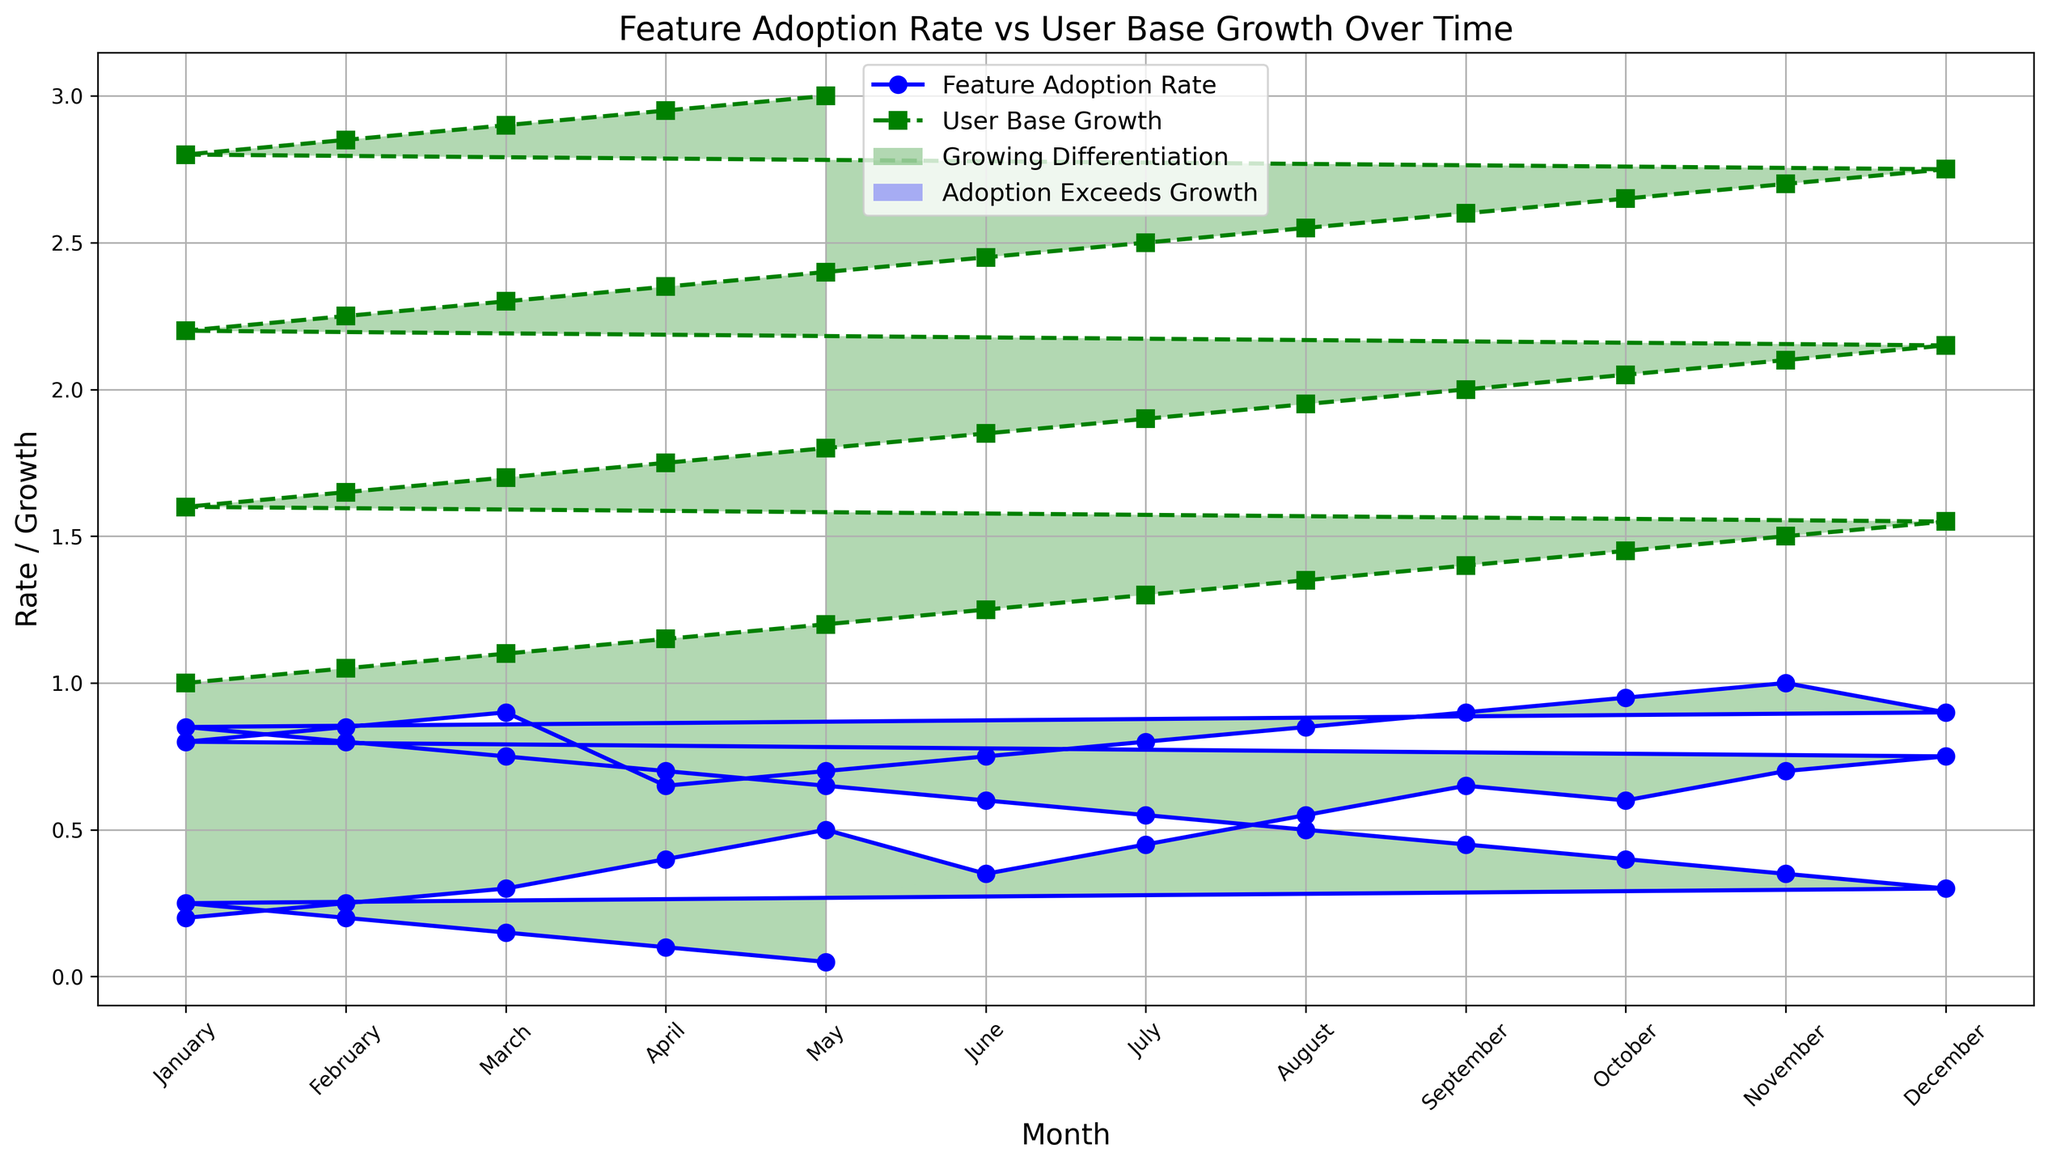What are the months where the Feature Adoption Rate is highest and lowest? We need to identify the months with the highest and lowest points on the blue line representing Feature Adoption Rate. The highest is observed in November (1.0), and the lowest in May (0.05).
Answer: November, May In which months does the Feature Adoption Rate exceed User Base Growth? We need to look for the months where the blue line (Feature Adoption Rate) is above the green line (User Base Growth). This occurs in November (1.0) and some subsequent months all the way to December before January when it starts dropping.
Answer: November, December What's the average User Base Growth over the months? To find the average, sum up all the User Base Growth values and divide by the number of data points. Sum all User Base Growth values and divide by 36. The sum is 73.5, so the average is 73.5 / 36.
Answer: 2.04 During which months is the gap between User Base Growth and Feature Adoption Rate largest? This is found by identifying the largest vertical distance between the green User Base Growth line and the blue Feature Adoption Rate line. The maximum gap is observed in May.
Answer: May Does the Feature Adoption Rate ever decline while User Base Growth is still increasing? If so, when? We need to find where the blue line (Feature Adoption Rate) is decreasing while the green line (User Base Growth) is increasing. This is visible around April of the third year.
Answer: Yes, April (third year) When does the Feature Adoption Rate reach 0.9 for the first time? Identify when the blue line first touches the value of 0.9. This occurs in March of the second year.
Answer: March (second year) Which months have the Feature Adoption Rate between 0.5 and 0.7, inclusive? Look for months where the blue line ranges between 0.5 and 0.7. These months are May (first year), July (first year), August (first year), September (first year), October (first year), May (second year) and April (third year).
Answer: Several months including May, July, August, September, October (first year), May, April (third year) What is the visual difference in the filled areas between the periods when Feature Adoption Rate exceeds User Base Growth and vice versa? The colors in the figure differ where the Feature Adoption Rate and User Base Growth cross each other. When the Feature Adoption Rate exceeds, the area is blue. When User Base Growth exceeds, the area is green.
Answer: Blue (Adoption exceeds), Green (Growth exceeds) How many months are there where Feature Adoption Rate and User Base Growth are equal? We need to visually search for intersections of the blue and green lines. This occurs at exactly one point in the data of November of the second year.
Answer: One month 